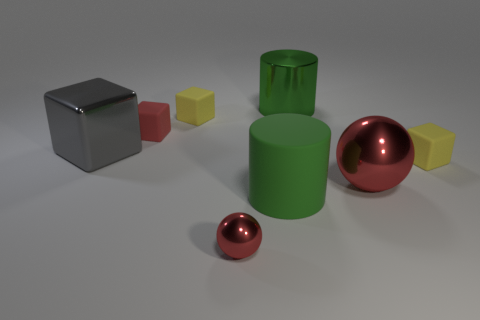Add 2 large gray blocks. How many objects exist? 10 Subtract all cylinders. How many objects are left? 6 Add 1 matte blocks. How many matte blocks are left? 4 Add 6 small cubes. How many small cubes exist? 9 Subtract 0 brown blocks. How many objects are left? 8 Subtract all tiny yellow blocks. Subtract all small shiny objects. How many objects are left? 5 